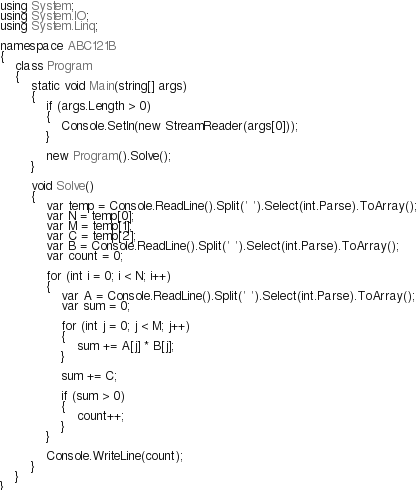<code> <loc_0><loc_0><loc_500><loc_500><_C#_>using System;
using System.IO;
using System.Linq;

namespace ABC121B
{
    class Program
    {
        static void Main(string[] args)
        {
            if (args.Length > 0)
            {
                Console.SetIn(new StreamReader(args[0]));
            }

            new Program().Solve();
        }

        void Solve()
        {
            var temp = Console.ReadLine().Split(' ').Select(int.Parse).ToArray();
            var N = temp[0];
            var M = temp[1];
            var C = temp[2];
            var B = Console.ReadLine().Split(' ').Select(int.Parse).ToArray();
            var count = 0;

            for (int i = 0; i < N; i++)
            {
                var A = Console.ReadLine().Split(' ').Select(int.Parse).ToArray();
                var sum = 0;

                for (int j = 0; j < M; j++)
                {
                    sum += A[j] * B[j];
                }

                sum += C;

                if (sum > 0)
                {
                    count++;
                }
            }

            Console.WriteLine(count);
        }
    }
}
</code> 